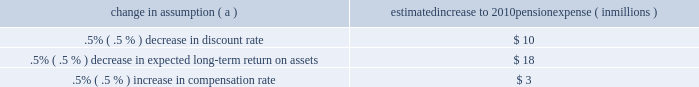Investment policy , which is described more fully in note 15 employee benefit plans in the notes to consolidated financial statements in item 8 of this report .
We calculate the expense associated with the pension plan and the assumptions and methods that we use include a policy of reflecting trust assets at their fair market value .
On an annual basis , we review the actuarial assumptions related to the pension plan , including the discount rate , the rate of compensation increase and the expected return on plan assets .
The discount rate and compensation increase assumptions do not significantly affect pension expense .
However , the expected long-term return on assets assumption does significantly affect pension expense .
Our expected long- term return on plan assets for determining net periodic pension expense has been 8.25% ( 8.25 % ) for the past three years .
The expected return on plan assets is a long-term assumption established by considering historical and anticipated returns of the asset classes invested in by the pension plan and the allocation strategy currently in place among those classes .
While this analysis gives appropriate consideration to recent asset performance and historical returns , the assumption represents a long-term prospective return .
We review this assumption at each measurement date and adjust it if warranted .
For purposes of setting and reviewing this assumption , 201clong- term 201d refers to the period over which the plan 2019s projected benefit obligation will be disbursed .
While year-to-year annual returns can vary significantly ( rates of return for the reporting years of 2009 , 2008 , and 2007 were +20.61% ( +20.61 % ) , -32.91% ( -32.91 % ) , and +7.57% ( +7.57 % ) , respectively ) , the assumption represents our estimate of long-term average prospective returns .
Our selection process references certain historical data and the current environment , but primarily utilizes qualitative judgment regarding future return expectations .
Recent annual returns may differ but , recognizing the volatility and unpredictability of investment returns , we generally do not change the assumption unless we modify our investment strategy or identify events that would alter our expectations of future returns .
To evaluate the continued reasonableness of our assumption , we examine a variety of viewpoints and data .
Various studies have shown that portfolios comprised primarily of us equity securities have returned approximately 10% ( 10 % ) over long periods of time , while us debt securities have returned approximately 6% ( 6 % ) annually over long periods .
Application of these historical returns to the plan 2019s allocation of equities and bonds produces a result between 8% ( 8 % ) and 8.5% ( 8.5 % ) and is one point of reference , among many other factors , that is taken into consideration .
We also examine the plan 2019s actual historical returns over various periods .
Recent experience is considered in our evaluation with appropriate consideration that , especially for short time periods , recent returns are not reliable indicators of future returns , and in many cases low returns in recent time periods are followed by higher returns in future periods ( and vice versa ) .
Acknowledging the potentially wide range for this assumption , we also annually examine the assumption used by other companies with similar pension investment strategies , so that we can ascertain whether our determinations markedly differ from other observers .
In all cases , however , this data simply informs our process , which places the greatest emphasis on our qualitative judgment of future investment returns , given the conditions existing at each annual measurement date .
The expected long-term return on plan assets for determining net periodic pension cost for 2009 was 8.25% ( 8.25 % ) , unchanged from 2008 .
During 2010 , we intend to decrease the midpoint of the plan 2019s target allocation range for equities by approximately five percentage points .
As a result of this change and taking into account all other factors described above , pnc will change the expected long-term return on plan assets to 8.00% ( 8.00 % ) for determining net periodic pension cost for 2010 .
Under current accounting rules , the difference between expected long-term returns and actual returns is accumulated and amortized to pension expense over future periods .
Each one percentage point difference in actual return compared with our expected return causes expense in subsequent years to change by up to $ 8 million as the impact is amortized into results of operations .
The table below reflects the estimated effects on pension expense of certain changes in annual assumptions , using 2010 estimated expense as a baseline .
Change in assumption ( a ) estimated increase to 2010 pension expense ( in millions ) .
( a ) the impact is the effect of changing the specified assumption while holding all other assumptions constant .
We currently estimate a pretax pension expense of $ 41 million in 2010 compared with pretax expense of $ 117 million in 2009 .
This year-over-year reduction was primarily due to the amortization impact of the favorable 2009 investment returns as compared with the expected long-term return assumption .
Our pension plan contribution requirements are not particularly sensitive to actuarial assumptions .
Investment performance has the most impact on contribution requirements and will drive the amount of permitted contributions in future years .
Also , current law , including the provisions of the pension protection act of 2006 , sets limits as to both minimum and maximum contributions to the plan .
We expect that the minimum required contributions under the law will be zero for 2010 .
We maintain other defined benefit plans that have a less significant effect on financial results , including various .
What is the estimated change in pretax pension expense between 2010 compared to 2009 in millions? 
Computations: (41 - 117)
Answer: -76.0. 